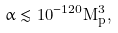<formula> <loc_0><loc_0><loc_500><loc_500>\alpha \lesssim 1 0 ^ { - 1 2 0 } M _ { p } ^ { 3 } ,</formula> 